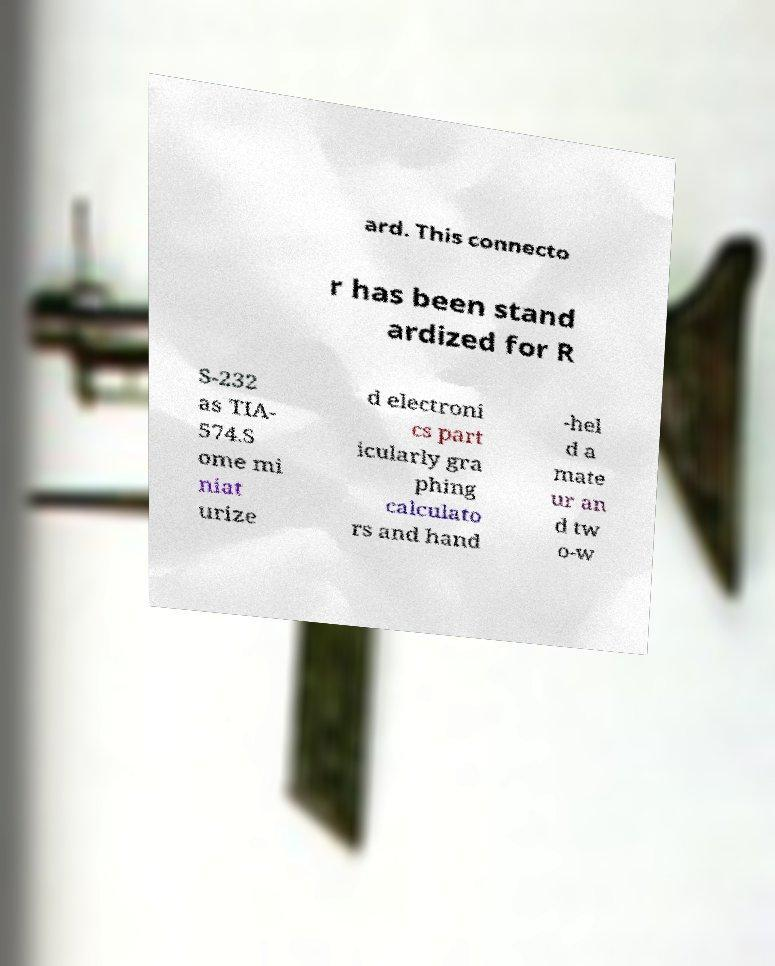I need the written content from this picture converted into text. Can you do that? ard. This connecto r has been stand ardized for R S-232 as TIA- 574.S ome mi niat urize d electroni cs part icularly gra phing calculato rs and hand -hel d a mate ur an d tw o-w 